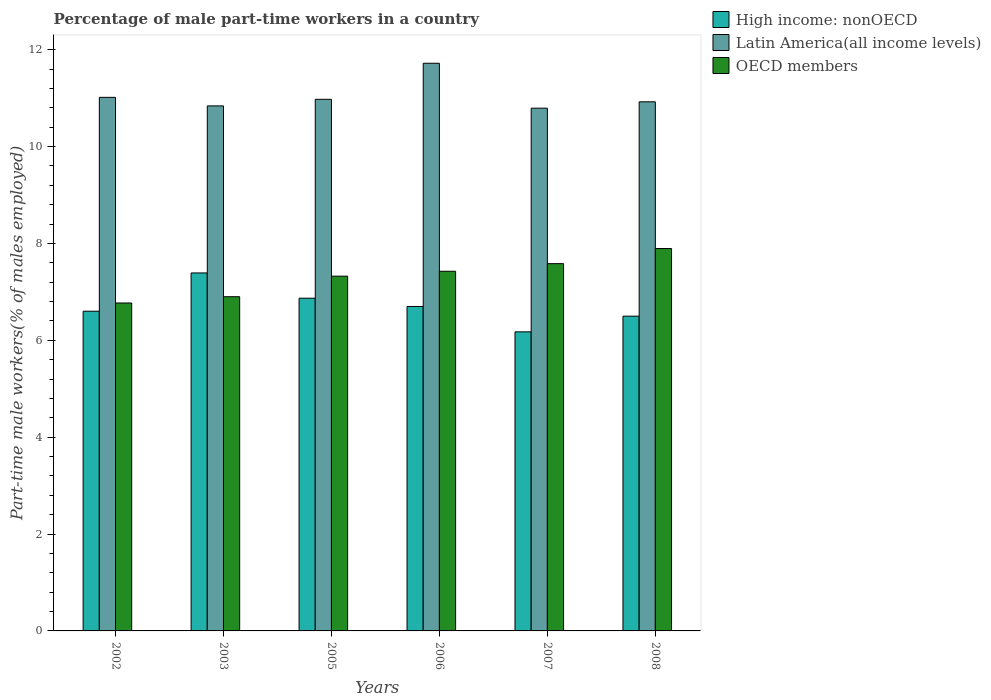How many bars are there on the 2nd tick from the left?
Provide a succinct answer. 3. What is the percentage of male part-time workers in OECD members in 2006?
Ensure brevity in your answer.  7.42. Across all years, what is the maximum percentage of male part-time workers in OECD members?
Keep it short and to the point. 7.89. Across all years, what is the minimum percentage of male part-time workers in OECD members?
Offer a very short reply. 6.77. In which year was the percentage of male part-time workers in High income: nonOECD maximum?
Your answer should be compact. 2003. In which year was the percentage of male part-time workers in Latin America(all income levels) minimum?
Offer a terse response. 2007. What is the total percentage of male part-time workers in High income: nonOECD in the graph?
Your answer should be very brief. 40.23. What is the difference between the percentage of male part-time workers in Latin America(all income levels) in 2006 and that in 2008?
Offer a terse response. 0.8. What is the difference between the percentage of male part-time workers in High income: nonOECD in 2008 and the percentage of male part-time workers in OECD members in 2007?
Offer a terse response. -1.08. What is the average percentage of male part-time workers in Latin America(all income levels) per year?
Give a very brief answer. 11.04. In the year 2007, what is the difference between the percentage of male part-time workers in Latin America(all income levels) and percentage of male part-time workers in High income: nonOECD?
Make the answer very short. 4.62. In how many years, is the percentage of male part-time workers in Latin America(all income levels) greater than 10.8 %?
Make the answer very short. 5. What is the ratio of the percentage of male part-time workers in High income: nonOECD in 2002 to that in 2008?
Your answer should be compact. 1.02. Is the difference between the percentage of male part-time workers in Latin America(all income levels) in 2005 and 2007 greater than the difference between the percentage of male part-time workers in High income: nonOECD in 2005 and 2007?
Provide a succinct answer. No. What is the difference between the highest and the second highest percentage of male part-time workers in High income: nonOECD?
Your answer should be very brief. 0.52. What is the difference between the highest and the lowest percentage of male part-time workers in Latin America(all income levels)?
Provide a succinct answer. 0.93. In how many years, is the percentage of male part-time workers in OECD members greater than the average percentage of male part-time workers in OECD members taken over all years?
Offer a terse response. 4. What does the 1st bar from the left in 2003 represents?
Your answer should be compact. High income: nonOECD. Is it the case that in every year, the sum of the percentage of male part-time workers in OECD members and percentage of male part-time workers in High income: nonOECD is greater than the percentage of male part-time workers in Latin America(all income levels)?
Make the answer very short. Yes. Are all the bars in the graph horizontal?
Keep it short and to the point. No. What is the difference between two consecutive major ticks on the Y-axis?
Offer a terse response. 2. Are the values on the major ticks of Y-axis written in scientific E-notation?
Make the answer very short. No. Does the graph contain grids?
Your answer should be very brief. No. How many legend labels are there?
Make the answer very short. 3. How are the legend labels stacked?
Ensure brevity in your answer.  Vertical. What is the title of the graph?
Your answer should be very brief. Percentage of male part-time workers in a country. What is the label or title of the Y-axis?
Make the answer very short. Part-time male workers(% of males employed). What is the Part-time male workers(% of males employed) of High income: nonOECD in 2002?
Offer a terse response. 6.6. What is the Part-time male workers(% of males employed) in Latin America(all income levels) in 2002?
Your answer should be very brief. 11.01. What is the Part-time male workers(% of males employed) of OECD members in 2002?
Offer a terse response. 6.77. What is the Part-time male workers(% of males employed) in High income: nonOECD in 2003?
Ensure brevity in your answer.  7.39. What is the Part-time male workers(% of males employed) in Latin America(all income levels) in 2003?
Offer a very short reply. 10.84. What is the Part-time male workers(% of males employed) in OECD members in 2003?
Make the answer very short. 6.9. What is the Part-time male workers(% of males employed) in High income: nonOECD in 2005?
Make the answer very short. 6.87. What is the Part-time male workers(% of males employed) in Latin America(all income levels) in 2005?
Offer a very short reply. 10.97. What is the Part-time male workers(% of males employed) of OECD members in 2005?
Make the answer very short. 7.32. What is the Part-time male workers(% of males employed) in High income: nonOECD in 2006?
Offer a very short reply. 6.7. What is the Part-time male workers(% of males employed) of Latin America(all income levels) in 2006?
Your response must be concise. 11.72. What is the Part-time male workers(% of males employed) of OECD members in 2006?
Your answer should be compact. 7.42. What is the Part-time male workers(% of males employed) in High income: nonOECD in 2007?
Your response must be concise. 6.17. What is the Part-time male workers(% of males employed) of Latin America(all income levels) in 2007?
Your answer should be very brief. 10.79. What is the Part-time male workers(% of males employed) in OECD members in 2007?
Make the answer very short. 7.58. What is the Part-time male workers(% of males employed) in High income: nonOECD in 2008?
Ensure brevity in your answer.  6.5. What is the Part-time male workers(% of males employed) in Latin America(all income levels) in 2008?
Ensure brevity in your answer.  10.92. What is the Part-time male workers(% of males employed) in OECD members in 2008?
Provide a succinct answer. 7.89. Across all years, what is the maximum Part-time male workers(% of males employed) of High income: nonOECD?
Offer a terse response. 7.39. Across all years, what is the maximum Part-time male workers(% of males employed) of Latin America(all income levels)?
Your answer should be very brief. 11.72. Across all years, what is the maximum Part-time male workers(% of males employed) in OECD members?
Provide a succinct answer. 7.89. Across all years, what is the minimum Part-time male workers(% of males employed) of High income: nonOECD?
Ensure brevity in your answer.  6.17. Across all years, what is the minimum Part-time male workers(% of males employed) in Latin America(all income levels)?
Your answer should be compact. 10.79. Across all years, what is the minimum Part-time male workers(% of males employed) in OECD members?
Provide a succinct answer. 6.77. What is the total Part-time male workers(% of males employed) in High income: nonOECD in the graph?
Ensure brevity in your answer.  40.23. What is the total Part-time male workers(% of males employed) of Latin America(all income levels) in the graph?
Make the answer very short. 66.26. What is the total Part-time male workers(% of males employed) in OECD members in the graph?
Provide a succinct answer. 43.89. What is the difference between the Part-time male workers(% of males employed) of High income: nonOECD in 2002 and that in 2003?
Make the answer very short. -0.79. What is the difference between the Part-time male workers(% of males employed) of Latin America(all income levels) in 2002 and that in 2003?
Provide a short and direct response. 0.18. What is the difference between the Part-time male workers(% of males employed) of OECD members in 2002 and that in 2003?
Provide a short and direct response. -0.13. What is the difference between the Part-time male workers(% of males employed) of High income: nonOECD in 2002 and that in 2005?
Your answer should be compact. -0.27. What is the difference between the Part-time male workers(% of males employed) in Latin America(all income levels) in 2002 and that in 2005?
Offer a terse response. 0.04. What is the difference between the Part-time male workers(% of males employed) in OECD members in 2002 and that in 2005?
Give a very brief answer. -0.55. What is the difference between the Part-time male workers(% of males employed) of High income: nonOECD in 2002 and that in 2006?
Offer a very short reply. -0.1. What is the difference between the Part-time male workers(% of males employed) in Latin America(all income levels) in 2002 and that in 2006?
Give a very brief answer. -0.7. What is the difference between the Part-time male workers(% of males employed) in OECD members in 2002 and that in 2006?
Provide a succinct answer. -0.66. What is the difference between the Part-time male workers(% of males employed) in High income: nonOECD in 2002 and that in 2007?
Make the answer very short. 0.43. What is the difference between the Part-time male workers(% of males employed) of Latin America(all income levels) in 2002 and that in 2007?
Provide a short and direct response. 0.22. What is the difference between the Part-time male workers(% of males employed) in OECD members in 2002 and that in 2007?
Ensure brevity in your answer.  -0.81. What is the difference between the Part-time male workers(% of males employed) in High income: nonOECD in 2002 and that in 2008?
Give a very brief answer. 0.1. What is the difference between the Part-time male workers(% of males employed) of Latin America(all income levels) in 2002 and that in 2008?
Your answer should be compact. 0.09. What is the difference between the Part-time male workers(% of males employed) of OECD members in 2002 and that in 2008?
Provide a succinct answer. -1.12. What is the difference between the Part-time male workers(% of males employed) of High income: nonOECD in 2003 and that in 2005?
Keep it short and to the point. 0.52. What is the difference between the Part-time male workers(% of males employed) in Latin America(all income levels) in 2003 and that in 2005?
Offer a very short reply. -0.14. What is the difference between the Part-time male workers(% of males employed) of OECD members in 2003 and that in 2005?
Your answer should be compact. -0.42. What is the difference between the Part-time male workers(% of males employed) of High income: nonOECD in 2003 and that in 2006?
Your answer should be very brief. 0.69. What is the difference between the Part-time male workers(% of males employed) in Latin America(all income levels) in 2003 and that in 2006?
Keep it short and to the point. -0.88. What is the difference between the Part-time male workers(% of males employed) of OECD members in 2003 and that in 2006?
Offer a terse response. -0.53. What is the difference between the Part-time male workers(% of males employed) in High income: nonOECD in 2003 and that in 2007?
Offer a very short reply. 1.22. What is the difference between the Part-time male workers(% of males employed) in Latin America(all income levels) in 2003 and that in 2007?
Ensure brevity in your answer.  0.05. What is the difference between the Part-time male workers(% of males employed) of OECD members in 2003 and that in 2007?
Provide a short and direct response. -0.68. What is the difference between the Part-time male workers(% of males employed) of High income: nonOECD in 2003 and that in 2008?
Offer a very short reply. 0.89. What is the difference between the Part-time male workers(% of males employed) of Latin America(all income levels) in 2003 and that in 2008?
Provide a succinct answer. -0.08. What is the difference between the Part-time male workers(% of males employed) of OECD members in 2003 and that in 2008?
Your answer should be compact. -0.99. What is the difference between the Part-time male workers(% of males employed) of High income: nonOECD in 2005 and that in 2006?
Provide a succinct answer. 0.17. What is the difference between the Part-time male workers(% of males employed) of Latin America(all income levels) in 2005 and that in 2006?
Your response must be concise. -0.74. What is the difference between the Part-time male workers(% of males employed) in OECD members in 2005 and that in 2006?
Provide a succinct answer. -0.1. What is the difference between the Part-time male workers(% of males employed) of High income: nonOECD in 2005 and that in 2007?
Your response must be concise. 0.7. What is the difference between the Part-time male workers(% of males employed) in Latin America(all income levels) in 2005 and that in 2007?
Your response must be concise. 0.18. What is the difference between the Part-time male workers(% of males employed) of OECD members in 2005 and that in 2007?
Make the answer very short. -0.26. What is the difference between the Part-time male workers(% of males employed) of High income: nonOECD in 2005 and that in 2008?
Keep it short and to the point. 0.37. What is the difference between the Part-time male workers(% of males employed) of Latin America(all income levels) in 2005 and that in 2008?
Provide a short and direct response. 0.05. What is the difference between the Part-time male workers(% of males employed) of OECD members in 2005 and that in 2008?
Ensure brevity in your answer.  -0.57. What is the difference between the Part-time male workers(% of males employed) in High income: nonOECD in 2006 and that in 2007?
Provide a succinct answer. 0.52. What is the difference between the Part-time male workers(% of males employed) of Latin America(all income levels) in 2006 and that in 2007?
Provide a short and direct response. 0.93. What is the difference between the Part-time male workers(% of males employed) in OECD members in 2006 and that in 2007?
Give a very brief answer. -0.16. What is the difference between the Part-time male workers(% of males employed) in High income: nonOECD in 2006 and that in 2008?
Offer a very short reply. 0.2. What is the difference between the Part-time male workers(% of males employed) in Latin America(all income levels) in 2006 and that in 2008?
Provide a succinct answer. 0.8. What is the difference between the Part-time male workers(% of males employed) in OECD members in 2006 and that in 2008?
Ensure brevity in your answer.  -0.47. What is the difference between the Part-time male workers(% of males employed) of High income: nonOECD in 2007 and that in 2008?
Your answer should be very brief. -0.32. What is the difference between the Part-time male workers(% of males employed) of Latin America(all income levels) in 2007 and that in 2008?
Make the answer very short. -0.13. What is the difference between the Part-time male workers(% of males employed) of OECD members in 2007 and that in 2008?
Offer a terse response. -0.31. What is the difference between the Part-time male workers(% of males employed) of High income: nonOECD in 2002 and the Part-time male workers(% of males employed) of Latin America(all income levels) in 2003?
Give a very brief answer. -4.24. What is the difference between the Part-time male workers(% of males employed) in High income: nonOECD in 2002 and the Part-time male workers(% of males employed) in OECD members in 2003?
Your answer should be very brief. -0.3. What is the difference between the Part-time male workers(% of males employed) in Latin America(all income levels) in 2002 and the Part-time male workers(% of males employed) in OECD members in 2003?
Offer a terse response. 4.12. What is the difference between the Part-time male workers(% of males employed) in High income: nonOECD in 2002 and the Part-time male workers(% of males employed) in Latin America(all income levels) in 2005?
Your answer should be very brief. -4.37. What is the difference between the Part-time male workers(% of males employed) of High income: nonOECD in 2002 and the Part-time male workers(% of males employed) of OECD members in 2005?
Offer a very short reply. -0.72. What is the difference between the Part-time male workers(% of males employed) in Latin America(all income levels) in 2002 and the Part-time male workers(% of males employed) in OECD members in 2005?
Ensure brevity in your answer.  3.69. What is the difference between the Part-time male workers(% of males employed) of High income: nonOECD in 2002 and the Part-time male workers(% of males employed) of Latin America(all income levels) in 2006?
Your answer should be compact. -5.12. What is the difference between the Part-time male workers(% of males employed) in High income: nonOECD in 2002 and the Part-time male workers(% of males employed) in OECD members in 2006?
Your answer should be compact. -0.82. What is the difference between the Part-time male workers(% of males employed) of Latin America(all income levels) in 2002 and the Part-time male workers(% of males employed) of OECD members in 2006?
Give a very brief answer. 3.59. What is the difference between the Part-time male workers(% of males employed) of High income: nonOECD in 2002 and the Part-time male workers(% of males employed) of Latin America(all income levels) in 2007?
Ensure brevity in your answer.  -4.19. What is the difference between the Part-time male workers(% of males employed) of High income: nonOECD in 2002 and the Part-time male workers(% of males employed) of OECD members in 2007?
Your answer should be compact. -0.98. What is the difference between the Part-time male workers(% of males employed) of Latin America(all income levels) in 2002 and the Part-time male workers(% of males employed) of OECD members in 2007?
Offer a very short reply. 3.43. What is the difference between the Part-time male workers(% of males employed) of High income: nonOECD in 2002 and the Part-time male workers(% of males employed) of Latin America(all income levels) in 2008?
Your answer should be very brief. -4.32. What is the difference between the Part-time male workers(% of males employed) of High income: nonOECD in 2002 and the Part-time male workers(% of males employed) of OECD members in 2008?
Offer a very short reply. -1.29. What is the difference between the Part-time male workers(% of males employed) of Latin America(all income levels) in 2002 and the Part-time male workers(% of males employed) of OECD members in 2008?
Give a very brief answer. 3.12. What is the difference between the Part-time male workers(% of males employed) in High income: nonOECD in 2003 and the Part-time male workers(% of males employed) in Latin America(all income levels) in 2005?
Give a very brief answer. -3.58. What is the difference between the Part-time male workers(% of males employed) of High income: nonOECD in 2003 and the Part-time male workers(% of males employed) of OECD members in 2005?
Ensure brevity in your answer.  0.07. What is the difference between the Part-time male workers(% of males employed) of Latin America(all income levels) in 2003 and the Part-time male workers(% of males employed) of OECD members in 2005?
Offer a very short reply. 3.51. What is the difference between the Part-time male workers(% of males employed) in High income: nonOECD in 2003 and the Part-time male workers(% of males employed) in Latin America(all income levels) in 2006?
Your answer should be compact. -4.33. What is the difference between the Part-time male workers(% of males employed) in High income: nonOECD in 2003 and the Part-time male workers(% of males employed) in OECD members in 2006?
Your answer should be compact. -0.04. What is the difference between the Part-time male workers(% of males employed) in Latin America(all income levels) in 2003 and the Part-time male workers(% of males employed) in OECD members in 2006?
Ensure brevity in your answer.  3.41. What is the difference between the Part-time male workers(% of males employed) in High income: nonOECD in 2003 and the Part-time male workers(% of males employed) in Latin America(all income levels) in 2007?
Offer a terse response. -3.4. What is the difference between the Part-time male workers(% of males employed) in High income: nonOECD in 2003 and the Part-time male workers(% of males employed) in OECD members in 2007?
Provide a succinct answer. -0.19. What is the difference between the Part-time male workers(% of males employed) of Latin America(all income levels) in 2003 and the Part-time male workers(% of males employed) of OECD members in 2007?
Offer a very short reply. 3.26. What is the difference between the Part-time male workers(% of males employed) of High income: nonOECD in 2003 and the Part-time male workers(% of males employed) of Latin America(all income levels) in 2008?
Keep it short and to the point. -3.53. What is the difference between the Part-time male workers(% of males employed) in High income: nonOECD in 2003 and the Part-time male workers(% of males employed) in OECD members in 2008?
Provide a succinct answer. -0.5. What is the difference between the Part-time male workers(% of males employed) in Latin America(all income levels) in 2003 and the Part-time male workers(% of males employed) in OECD members in 2008?
Ensure brevity in your answer.  2.94. What is the difference between the Part-time male workers(% of males employed) of High income: nonOECD in 2005 and the Part-time male workers(% of males employed) of Latin America(all income levels) in 2006?
Your response must be concise. -4.85. What is the difference between the Part-time male workers(% of males employed) in High income: nonOECD in 2005 and the Part-time male workers(% of males employed) in OECD members in 2006?
Provide a succinct answer. -0.56. What is the difference between the Part-time male workers(% of males employed) of Latin America(all income levels) in 2005 and the Part-time male workers(% of males employed) of OECD members in 2006?
Your response must be concise. 3.55. What is the difference between the Part-time male workers(% of males employed) in High income: nonOECD in 2005 and the Part-time male workers(% of males employed) in Latin America(all income levels) in 2007?
Offer a terse response. -3.92. What is the difference between the Part-time male workers(% of males employed) of High income: nonOECD in 2005 and the Part-time male workers(% of males employed) of OECD members in 2007?
Offer a very short reply. -0.71. What is the difference between the Part-time male workers(% of males employed) in Latin America(all income levels) in 2005 and the Part-time male workers(% of males employed) in OECD members in 2007?
Ensure brevity in your answer.  3.39. What is the difference between the Part-time male workers(% of males employed) of High income: nonOECD in 2005 and the Part-time male workers(% of males employed) of Latin America(all income levels) in 2008?
Your answer should be compact. -4.05. What is the difference between the Part-time male workers(% of males employed) of High income: nonOECD in 2005 and the Part-time male workers(% of males employed) of OECD members in 2008?
Ensure brevity in your answer.  -1.03. What is the difference between the Part-time male workers(% of males employed) of Latin America(all income levels) in 2005 and the Part-time male workers(% of males employed) of OECD members in 2008?
Give a very brief answer. 3.08. What is the difference between the Part-time male workers(% of males employed) of High income: nonOECD in 2006 and the Part-time male workers(% of males employed) of Latin America(all income levels) in 2007?
Offer a terse response. -4.09. What is the difference between the Part-time male workers(% of males employed) in High income: nonOECD in 2006 and the Part-time male workers(% of males employed) in OECD members in 2007?
Your answer should be very brief. -0.88. What is the difference between the Part-time male workers(% of males employed) in Latin America(all income levels) in 2006 and the Part-time male workers(% of males employed) in OECD members in 2007?
Make the answer very short. 4.14. What is the difference between the Part-time male workers(% of males employed) of High income: nonOECD in 2006 and the Part-time male workers(% of males employed) of Latin America(all income levels) in 2008?
Make the answer very short. -4.22. What is the difference between the Part-time male workers(% of males employed) in High income: nonOECD in 2006 and the Part-time male workers(% of males employed) in OECD members in 2008?
Offer a terse response. -1.2. What is the difference between the Part-time male workers(% of males employed) of Latin America(all income levels) in 2006 and the Part-time male workers(% of males employed) of OECD members in 2008?
Your answer should be compact. 3.82. What is the difference between the Part-time male workers(% of males employed) of High income: nonOECD in 2007 and the Part-time male workers(% of males employed) of Latin America(all income levels) in 2008?
Provide a short and direct response. -4.75. What is the difference between the Part-time male workers(% of males employed) of High income: nonOECD in 2007 and the Part-time male workers(% of males employed) of OECD members in 2008?
Make the answer very short. -1.72. What is the difference between the Part-time male workers(% of males employed) of Latin America(all income levels) in 2007 and the Part-time male workers(% of males employed) of OECD members in 2008?
Make the answer very short. 2.9. What is the average Part-time male workers(% of males employed) of High income: nonOECD per year?
Provide a short and direct response. 6.7. What is the average Part-time male workers(% of males employed) in Latin America(all income levels) per year?
Your answer should be very brief. 11.04. What is the average Part-time male workers(% of males employed) in OECD members per year?
Provide a short and direct response. 7.32. In the year 2002, what is the difference between the Part-time male workers(% of males employed) in High income: nonOECD and Part-time male workers(% of males employed) in Latin America(all income levels)?
Keep it short and to the point. -4.41. In the year 2002, what is the difference between the Part-time male workers(% of males employed) in High income: nonOECD and Part-time male workers(% of males employed) in OECD members?
Offer a terse response. -0.17. In the year 2002, what is the difference between the Part-time male workers(% of males employed) of Latin America(all income levels) and Part-time male workers(% of males employed) of OECD members?
Ensure brevity in your answer.  4.25. In the year 2003, what is the difference between the Part-time male workers(% of males employed) in High income: nonOECD and Part-time male workers(% of males employed) in Latin America(all income levels)?
Provide a short and direct response. -3.45. In the year 2003, what is the difference between the Part-time male workers(% of males employed) of High income: nonOECD and Part-time male workers(% of males employed) of OECD members?
Make the answer very short. 0.49. In the year 2003, what is the difference between the Part-time male workers(% of males employed) in Latin America(all income levels) and Part-time male workers(% of males employed) in OECD members?
Offer a terse response. 3.94. In the year 2005, what is the difference between the Part-time male workers(% of males employed) of High income: nonOECD and Part-time male workers(% of males employed) of Latin America(all income levels)?
Offer a very short reply. -4.11. In the year 2005, what is the difference between the Part-time male workers(% of males employed) in High income: nonOECD and Part-time male workers(% of males employed) in OECD members?
Your answer should be very brief. -0.45. In the year 2005, what is the difference between the Part-time male workers(% of males employed) in Latin America(all income levels) and Part-time male workers(% of males employed) in OECD members?
Provide a short and direct response. 3.65. In the year 2006, what is the difference between the Part-time male workers(% of males employed) in High income: nonOECD and Part-time male workers(% of males employed) in Latin America(all income levels)?
Your answer should be compact. -5.02. In the year 2006, what is the difference between the Part-time male workers(% of males employed) in High income: nonOECD and Part-time male workers(% of males employed) in OECD members?
Ensure brevity in your answer.  -0.73. In the year 2006, what is the difference between the Part-time male workers(% of males employed) in Latin America(all income levels) and Part-time male workers(% of males employed) in OECD members?
Offer a terse response. 4.29. In the year 2007, what is the difference between the Part-time male workers(% of males employed) of High income: nonOECD and Part-time male workers(% of males employed) of Latin America(all income levels)?
Make the answer very short. -4.62. In the year 2007, what is the difference between the Part-time male workers(% of males employed) in High income: nonOECD and Part-time male workers(% of males employed) in OECD members?
Ensure brevity in your answer.  -1.41. In the year 2007, what is the difference between the Part-time male workers(% of males employed) in Latin America(all income levels) and Part-time male workers(% of males employed) in OECD members?
Provide a short and direct response. 3.21. In the year 2008, what is the difference between the Part-time male workers(% of males employed) of High income: nonOECD and Part-time male workers(% of males employed) of Latin America(all income levels)?
Provide a short and direct response. -4.42. In the year 2008, what is the difference between the Part-time male workers(% of males employed) in High income: nonOECD and Part-time male workers(% of males employed) in OECD members?
Provide a short and direct response. -1.4. In the year 2008, what is the difference between the Part-time male workers(% of males employed) in Latin America(all income levels) and Part-time male workers(% of males employed) in OECD members?
Give a very brief answer. 3.03. What is the ratio of the Part-time male workers(% of males employed) in High income: nonOECD in 2002 to that in 2003?
Keep it short and to the point. 0.89. What is the ratio of the Part-time male workers(% of males employed) of Latin America(all income levels) in 2002 to that in 2003?
Your answer should be compact. 1.02. What is the ratio of the Part-time male workers(% of males employed) in OECD members in 2002 to that in 2003?
Provide a succinct answer. 0.98. What is the ratio of the Part-time male workers(% of males employed) in High income: nonOECD in 2002 to that in 2005?
Ensure brevity in your answer.  0.96. What is the ratio of the Part-time male workers(% of males employed) in Latin America(all income levels) in 2002 to that in 2005?
Keep it short and to the point. 1. What is the ratio of the Part-time male workers(% of males employed) in OECD members in 2002 to that in 2005?
Offer a terse response. 0.92. What is the ratio of the Part-time male workers(% of males employed) in High income: nonOECD in 2002 to that in 2006?
Provide a short and direct response. 0.99. What is the ratio of the Part-time male workers(% of males employed) of Latin America(all income levels) in 2002 to that in 2006?
Your response must be concise. 0.94. What is the ratio of the Part-time male workers(% of males employed) in OECD members in 2002 to that in 2006?
Ensure brevity in your answer.  0.91. What is the ratio of the Part-time male workers(% of males employed) in High income: nonOECD in 2002 to that in 2007?
Give a very brief answer. 1.07. What is the ratio of the Part-time male workers(% of males employed) in Latin America(all income levels) in 2002 to that in 2007?
Keep it short and to the point. 1.02. What is the ratio of the Part-time male workers(% of males employed) in OECD members in 2002 to that in 2007?
Provide a succinct answer. 0.89. What is the ratio of the Part-time male workers(% of males employed) of High income: nonOECD in 2002 to that in 2008?
Your answer should be compact. 1.02. What is the ratio of the Part-time male workers(% of males employed) in Latin America(all income levels) in 2002 to that in 2008?
Ensure brevity in your answer.  1.01. What is the ratio of the Part-time male workers(% of males employed) of OECD members in 2002 to that in 2008?
Your answer should be very brief. 0.86. What is the ratio of the Part-time male workers(% of males employed) in High income: nonOECD in 2003 to that in 2005?
Offer a very short reply. 1.08. What is the ratio of the Part-time male workers(% of males employed) of Latin America(all income levels) in 2003 to that in 2005?
Give a very brief answer. 0.99. What is the ratio of the Part-time male workers(% of males employed) of OECD members in 2003 to that in 2005?
Your response must be concise. 0.94. What is the ratio of the Part-time male workers(% of males employed) in High income: nonOECD in 2003 to that in 2006?
Your answer should be very brief. 1.1. What is the ratio of the Part-time male workers(% of males employed) in Latin America(all income levels) in 2003 to that in 2006?
Offer a very short reply. 0.92. What is the ratio of the Part-time male workers(% of males employed) in OECD members in 2003 to that in 2006?
Your response must be concise. 0.93. What is the ratio of the Part-time male workers(% of males employed) in High income: nonOECD in 2003 to that in 2007?
Your answer should be very brief. 1.2. What is the ratio of the Part-time male workers(% of males employed) of OECD members in 2003 to that in 2007?
Your answer should be very brief. 0.91. What is the ratio of the Part-time male workers(% of males employed) of High income: nonOECD in 2003 to that in 2008?
Provide a short and direct response. 1.14. What is the ratio of the Part-time male workers(% of males employed) in Latin America(all income levels) in 2003 to that in 2008?
Make the answer very short. 0.99. What is the ratio of the Part-time male workers(% of males employed) in OECD members in 2003 to that in 2008?
Offer a very short reply. 0.87. What is the ratio of the Part-time male workers(% of males employed) in High income: nonOECD in 2005 to that in 2006?
Your answer should be very brief. 1.03. What is the ratio of the Part-time male workers(% of males employed) in Latin America(all income levels) in 2005 to that in 2006?
Your answer should be very brief. 0.94. What is the ratio of the Part-time male workers(% of males employed) of OECD members in 2005 to that in 2006?
Provide a short and direct response. 0.99. What is the ratio of the Part-time male workers(% of males employed) of High income: nonOECD in 2005 to that in 2007?
Keep it short and to the point. 1.11. What is the ratio of the Part-time male workers(% of males employed) of OECD members in 2005 to that in 2007?
Make the answer very short. 0.97. What is the ratio of the Part-time male workers(% of males employed) of High income: nonOECD in 2005 to that in 2008?
Your answer should be very brief. 1.06. What is the ratio of the Part-time male workers(% of males employed) of Latin America(all income levels) in 2005 to that in 2008?
Provide a short and direct response. 1. What is the ratio of the Part-time male workers(% of males employed) in OECD members in 2005 to that in 2008?
Give a very brief answer. 0.93. What is the ratio of the Part-time male workers(% of males employed) of High income: nonOECD in 2006 to that in 2007?
Your response must be concise. 1.08. What is the ratio of the Part-time male workers(% of males employed) of Latin America(all income levels) in 2006 to that in 2007?
Give a very brief answer. 1.09. What is the ratio of the Part-time male workers(% of males employed) in OECD members in 2006 to that in 2007?
Ensure brevity in your answer.  0.98. What is the ratio of the Part-time male workers(% of males employed) of High income: nonOECD in 2006 to that in 2008?
Your answer should be very brief. 1.03. What is the ratio of the Part-time male workers(% of males employed) of Latin America(all income levels) in 2006 to that in 2008?
Keep it short and to the point. 1.07. What is the ratio of the Part-time male workers(% of males employed) in OECD members in 2006 to that in 2008?
Give a very brief answer. 0.94. What is the ratio of the Part-time male workers(% of males employed) in High income: nonOECD in 2007 to that in 2008?
Give a very brief answer. 0.95. What is the ratio of the Part-time male workers(% of males employed) in OECD members in 2007 to that in 2008?
Ensure brevity in your answer.  0.96. What is the difference between the highest and the second highest Part-time male workers(% of males employed) of High income: nonOECD?
Provide a succinct answer. 0.52. What is the difference between the highest and the second highest Part-time male workers(% of males employed) of Latin America(all income levels)?
Provide a succinct answer. 0.7. What is the difference between the highest and the second highest Part-time male workers(% of males employed) in OECD members?
Ensure brevity in your answer.  0.31. What is the difference between the highest and the lowest Part-time male workers(% of males employed) in High income: nonOECD?
Provide a succinct answer. 1.22. What is the difference between the highest and the lowest Part-time male workers(% of males employed) in Latin America(all income levels)?
Offer a very short reply. 0.93. What is the difference between the highest and the lowest Part-time male workers(% of males employed) of OECD members?
Offer a terse response. 1.12. 